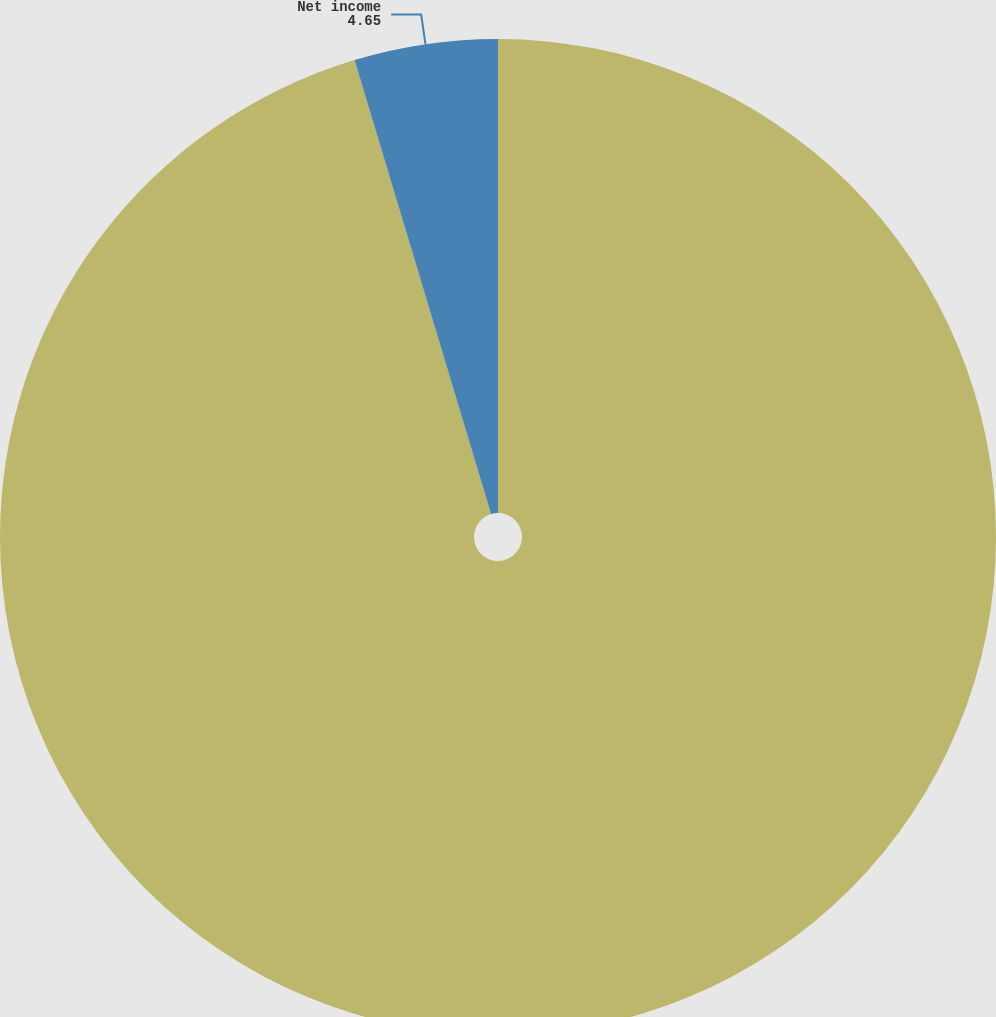Convert chart. <chart><loc_0><loc_0><loc_500><loc_500><pie_chart><fcel>Total revenues(a)<fcel>Net income<nl><fcel>95.35%<fcel>4.65%<nl></chart> 